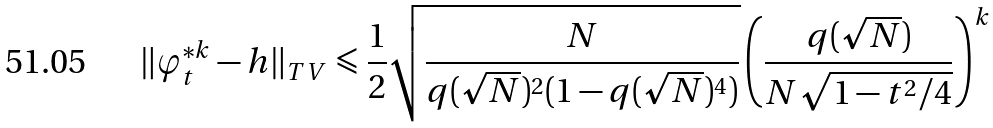Convert formula to latex. <formula><loc_0><loc_0><loc_500><loc_500>\| \varphi _ { t } ^ { \ast k } - h \| _ { T V } \leqslant \frac { 1 } { 2 } \sqrt { \frac { N } { q ( \sqrt { N } ) ^ { 2 } ( 1 - q ( \sqrt { N } ) ^ { 4 } ) } } \left ( \frac { q ( \sqrt { N } ) } { N \sqrt { 1 - t ^ { 2 } / 4 } } \right ) ^ { k }</formula> 